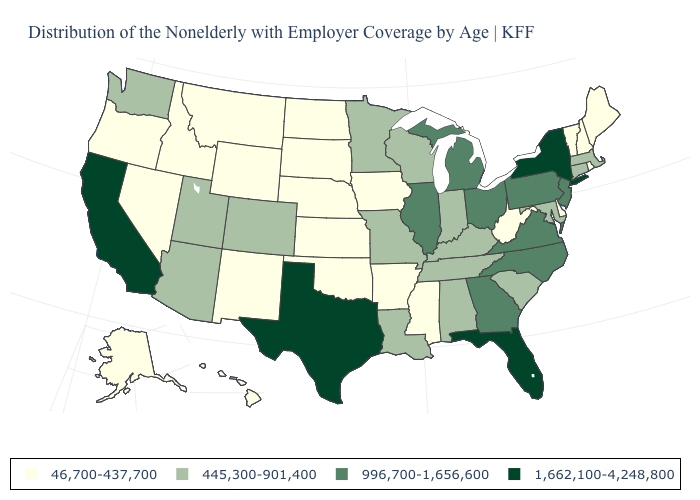What is the highest value in the USA?
Quick response, please. 1,662,100-4,248,800. What is the value of New York?
Write a very short answer. 1,662,100-4,248,800. Name the states that have a value in the range 445,300-901,400?
Concise answer only. Alabama, Arizona, Colorado, Connecticut, Indiana, Kentucky, Louisiana, Maryland, Massachusetts, Minnesota, Missouri, South Carolina, Tennessee, Utah, Washington, Wisconsin. Does the first symbol in the legend represent the smallest category?
Short answer required. Yes. Does New York have the highest value in the Northeast?
Keep it brief. Yes. Name the states that have a value in the range 1,662,100-4,248,800?
Answer briefly. California, Florida, New York, Texas. Name the states that have a value in the range 445,300-901,400?
Quick response, please. Alabama, Arizona, Colorado, Connecticut, Indiana, Kentucky, Louisiana, Maryland, Massachusetts, Minnesota, Missouri, South Carolina, Tennessee, Utah, Washington, Wisconsin. Does the map have missing data?
Keep it brief. No. What is the value of Indiana?
Keep it brief. 445,300-901,400. Which states hav the highest value in the South?
Keep it brief. Florida, Texas. Which states have the lowest value in the USA?
Quick response, please. Alaska, Arkansas, Delaware, Hawaii, Idaho, Iowa, Kansas, Maine, Mississippi, Montana, Nebraska, Nevada, New Hampshire, New Mexico, North Dakota, Oklahoma, Oregon, Rhode Island, South Dakota, Vermont, West Virginia, Wyoming. Name the states that have a value in the range 445,300-901,400?
Short answer required. Alabama, Arizona, Colorado, Connecticut, Indiana, Kentucky, Louisiana, Maryland, Massachusetts, Minnesota, Missouri, South Carolina, Tennessee, Utah, Washington, Wisconsin. Does the map have missing data?
Keep it brief. No. 